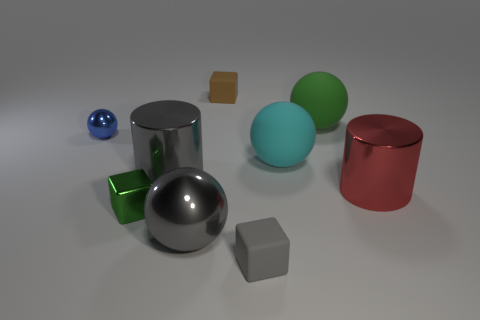Subtract all gray cubes. How many cubes are left? 2 Subtract all green cubes. How many cubes are left? 2 Add 1 large cyan balls. How many objects exist? 10 Subtract 2 spheres. How many spheres are left? 2 Add 7 cyan matte things. How many cyan matte things are left? 8 Add 7 cubes. How many cubes exist? 10 Subtract 0 red cubes. How many objects are left? 9 Subtract all cubes. How many objects are left? 6 Subtract all cyan blocks. Subtract all cyan spheres. How many blocks are left? 3 Subtract all red blocks. How many gray balls are left? 1 